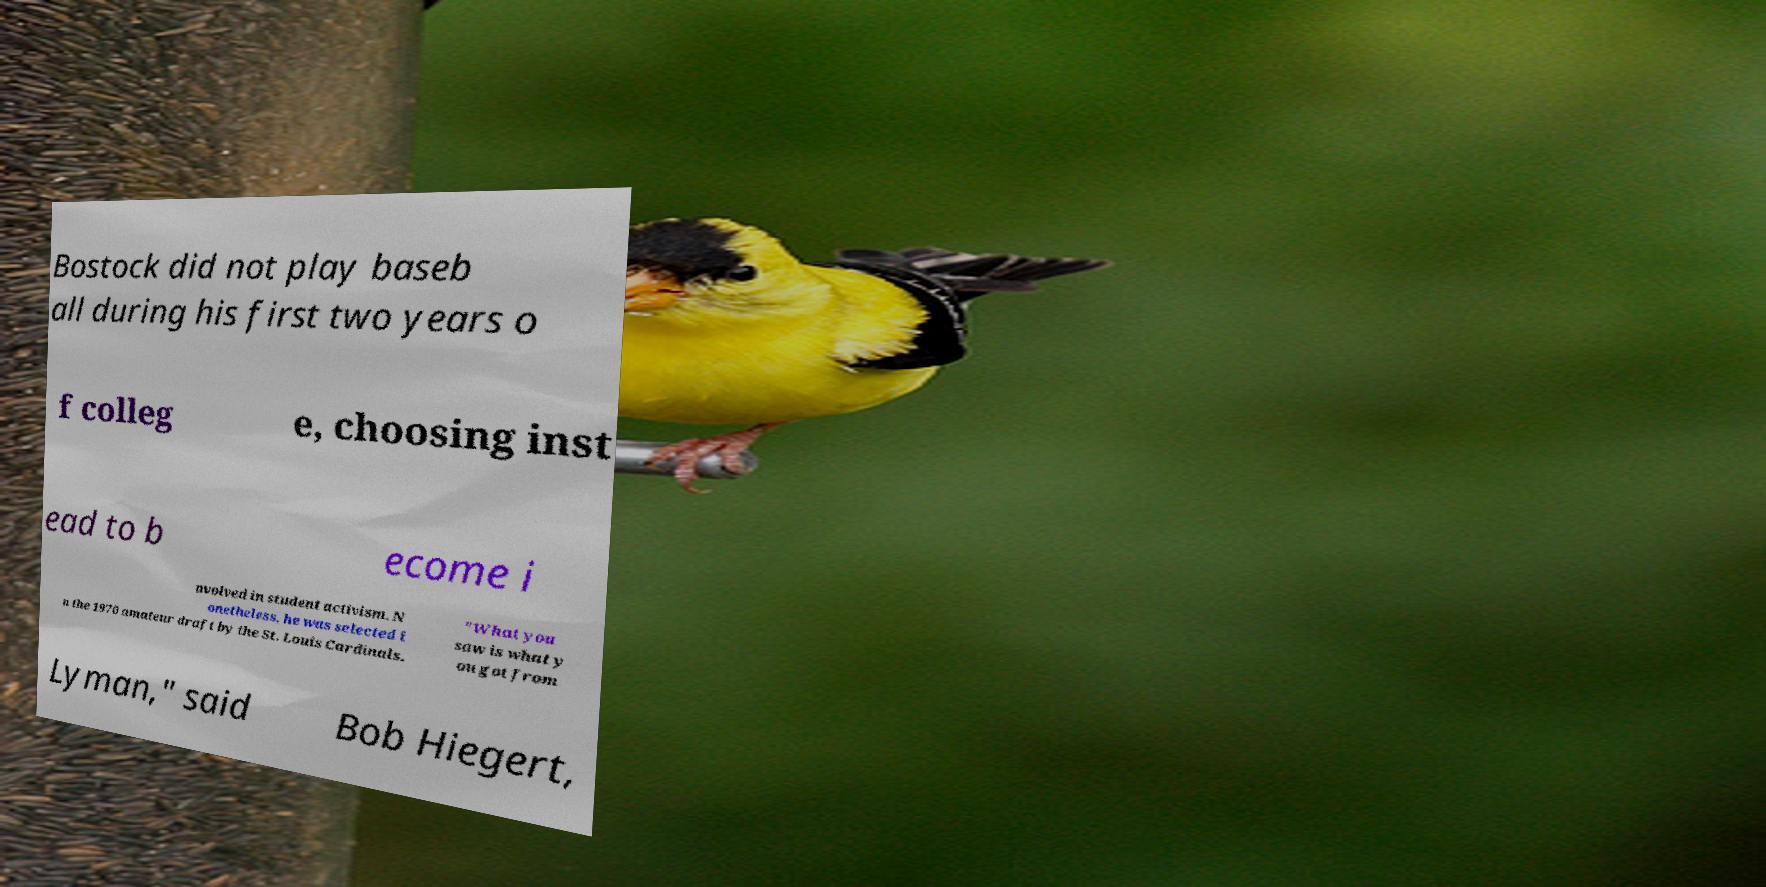Can you accurately transcribe the text from the provided image for me? Bostock did not play baseb all during his first two years o f colleg e, choosing inst ead to b ecome i nvolved in student activism. N onetheless, he was selected i n the 1970 amateur draft by the St. Louis Cardinals. "What you saw is what y ou got from Lyman," said Bob Hiegert, 